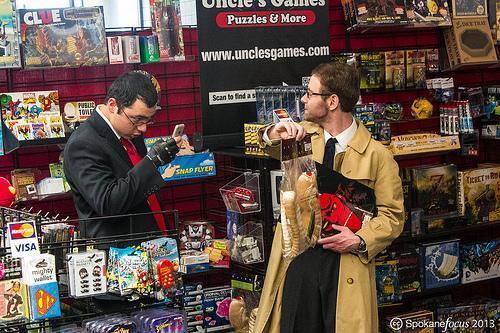How many men are in the photo?
Give a very brief answer. 2. 